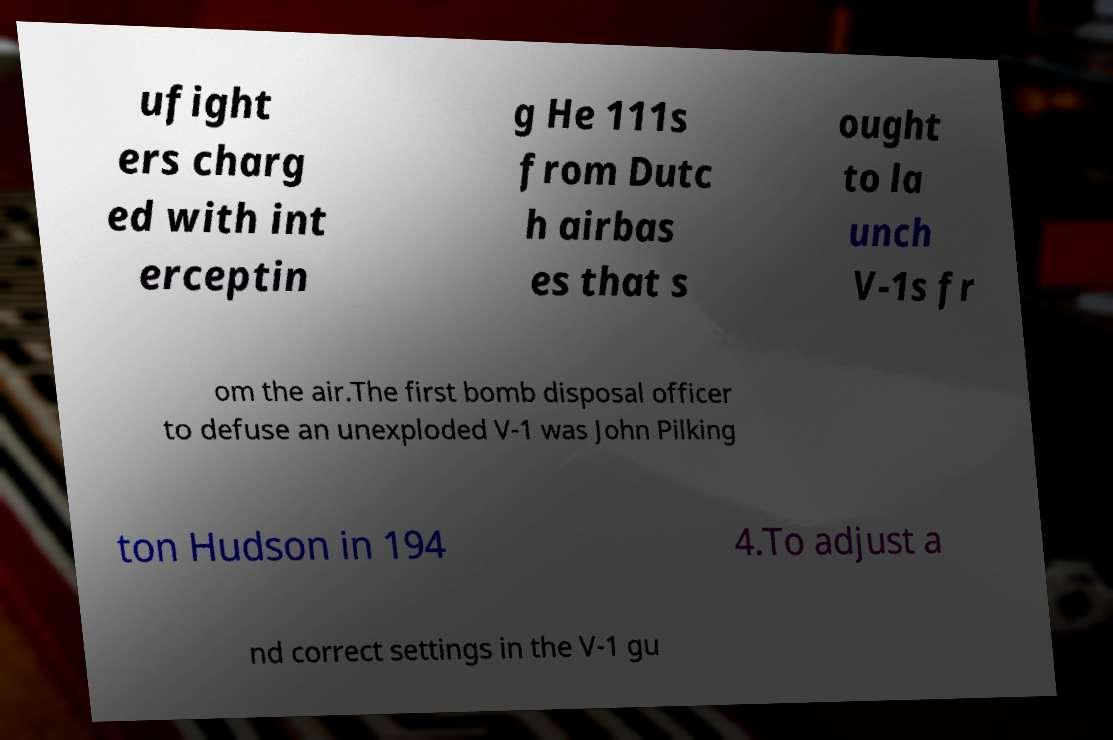What messages or text are displayed in this image? I need them in a readable, typed format. ufight ers charg ed with int erceptin g He 111s from Dutc h airbas es that s ought to la unch V-1s fr om the air.The first bomb disposal officer to defuse an unexploded V-1 was John Pilking ton Hudson in 194 4.To adjust a nd correct settings in the V-1 gu 